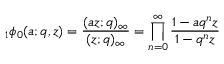<formula> <loc_0><loc_0><loc_500><loc_500>\, _ { 1 } \phi _ { 0 } ( a ; q , z ) = { \frac { ( a z ; q ) _ { \infty } } { ( z ; q ) _ { \infty } } } = \prod _ { n = 0 } ^ { \infty } { \frac { 1 - a q ^ { n } z } { 1 - q ^ { n } z } }</formula> 